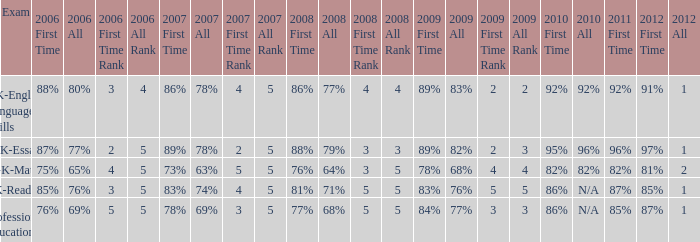What is the percentage for all in 2007 when all in 2006 was 65%? 63%. 